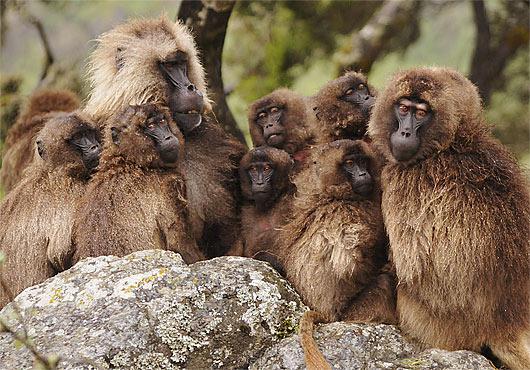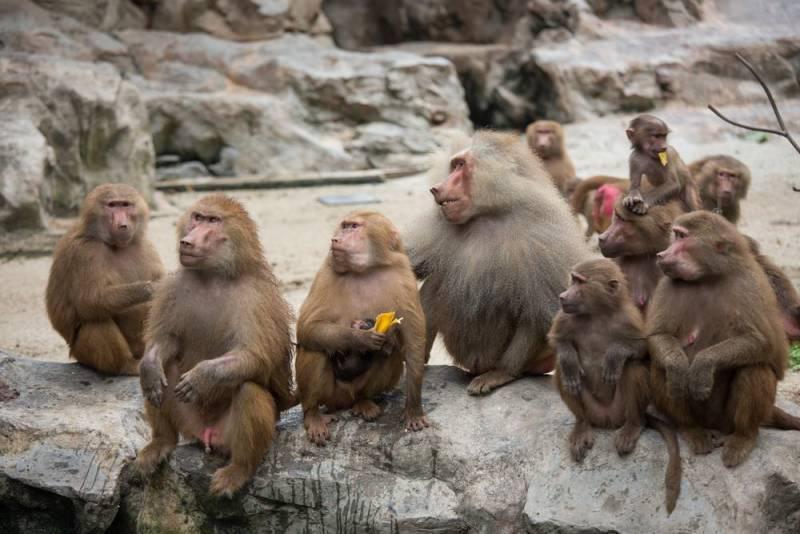The first image is the image on the left, the second image is the image on the right. Considering the images on both sides, is "An image shows only a solitary monkey sitting on a rock." valid? Answer yes or no. No. 